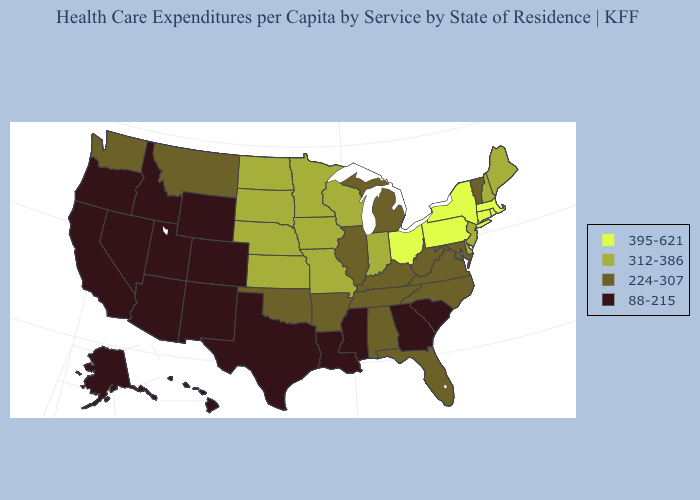What is the value of Nevada?
Answer briefly. 88-215. Which states hav the highest value in the MidWest?
Answer briefly. Ohio. Does Wyoming have the same value as Utah?
Keep it brief. Yes. Does Florida have the same value as South Carolina?
Short answer required. No. Does South Dakota have the highest value in the USA?
Concise answer only. No. Does Vermont have the lowest value in the Northeast?
Concise answer only. Yes. What is the value of Ohio?
Concise answer only. 395-621. What is the value of Mississippi?
Be succinct. 88-215. Name the states that have a value in the range 224-307?
Concise answer only. Alabama, Arkansas, Florida, Illinois, Kentucky, Maryland, Michigan, Montana, North Carolina, Oklahoma, Tennessee, Vermont, Virginia, Washington, West Virginia. Which states have the lowest value in the USA?
Write a very short answer. Alaska, Arizona, California, Colorado, Georgia, Hawaii, Idaho, Louisiana, Mississippi, Nevada, New Mexico, Oregon, South Carolina, Texas, Utah, Wyoming. What is the value of New Hampshire?
Give a very brief answer. 312-386. Which states hav the highest value in the West?
Quick response, please. Montana, Washington. Name the states that have a value in the range 312-386?
Write a very short answer. Delaware, Indiana, Iowa, Kansas, Maine, Minnesota, Missouri, Nebraska, New Hampshire, New Jersey, North Dakota, South Dakota, Wisconsin. Does Oklahoma have the lowest value in the South?
Concise answer only. No. Does Arizona have the highest value in the USA?
Write a very short answer. No. 